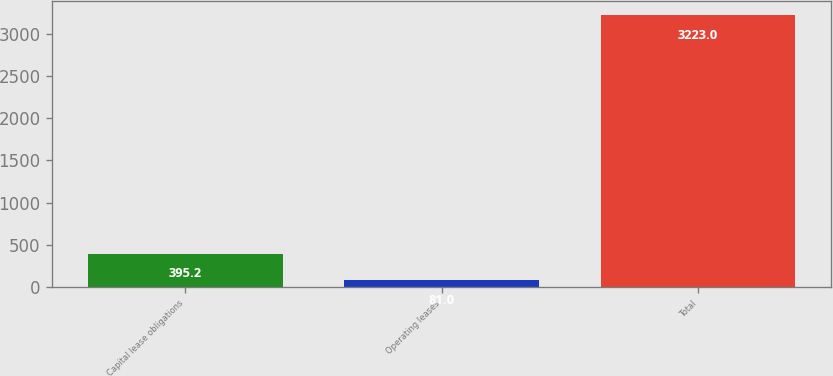Convert chart. <chart><loc_0><loc_0><loc_500><loc_500><bar_chart><fcel>Capital lease obligations<fcel>Operating leases<fcel>Total<nl><fcel>395.2<fcel>81<fcel>3223<nl></chart> 